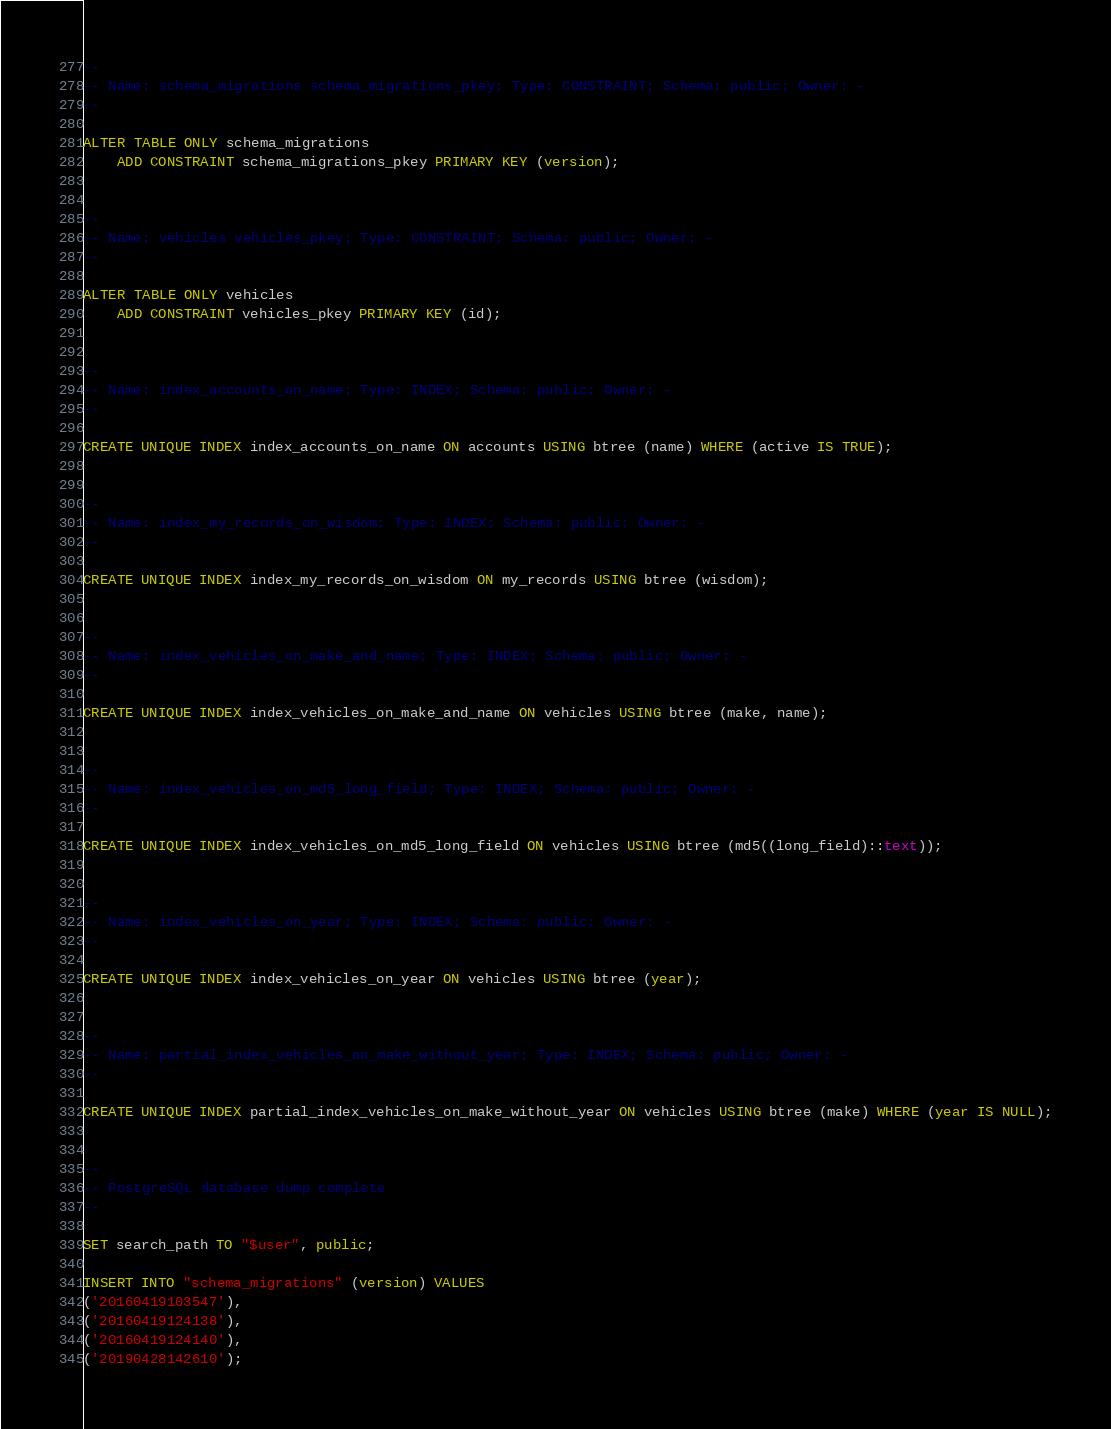<code> <loc_0><loc_0><loc_500><loc_500><_SQL_>

--
-- Name: schema_migrations schema_migrations_pkey; Type: CONSTRAINT; Schema: public; Owner: -
--

ALTER TABLE ONLY schema_migrations
    ADD CONSTRAINT schema_migrations_pkey PRIMARY KEY (version);


--
-- Name: vehicles vehicles_pkey; Type: CONSTRAINT; Schema: public; Owner: -
--

ALTER TABLE ONLY vehicles
    ADD CONSTRAINT vehicles_pkey PRIMARY KEY (id);


--
-- Name: index_accounts_on_name; Type: INDEX; Schema: public; Owner: -
--

CREATE UNIQUE INDEX index_accounts_on_name ON accounts USING btree (name) WHERE (active IS TRUE);


--
-- Name: index_my_records_on_wisdom; Type: INDEX; Schema: public; Owner: -
--

CREATE UNIQUE INDEX index_my_records_on_wisdom ON my_records USING btree (wisdom);


--
-- Name: index_vehicles_on_make_and_name; Type: INDEX; Schema: public; Owner: -
--

CREATE UNIQUE INDEX index_vehicles_on_make_and_name ON vehicles USING btree (make, name);


--
-- Name: index_vehicles_on_md5_long_field; Type: INDEX; Schema: public; Owner: -
--

CREATE UNIQUE INDEX index_vehicles_on_md5_long_field ON vehicles USING btree (md5((long_field)::text));


--
-- Name: index_vehicles_on_year; Type: INDEX; Schema: public; Owner: -
--

CREATE UNIQUE INDEX index_vehicles_on_year ON vehicles USING btree (year);


--
-- Name: partial_index_vehicles_on_make_without_year; Type: INDEX; Schema: public; Owner: -
--

CREATE UNIQUE INDEX partial_index_vehicles_on_make_without_year ON vehicles USING btree (make) WHERE (year IS NULL);


--
-- PostgreSQL database dump complete
--

SET search_path TO "$user", public;

INSERT INTO "schema_migrations" (version) VALUES
('20160419103547'),
('20160419124138'),
('20160419124140'),
('20190428142610');


</code> 